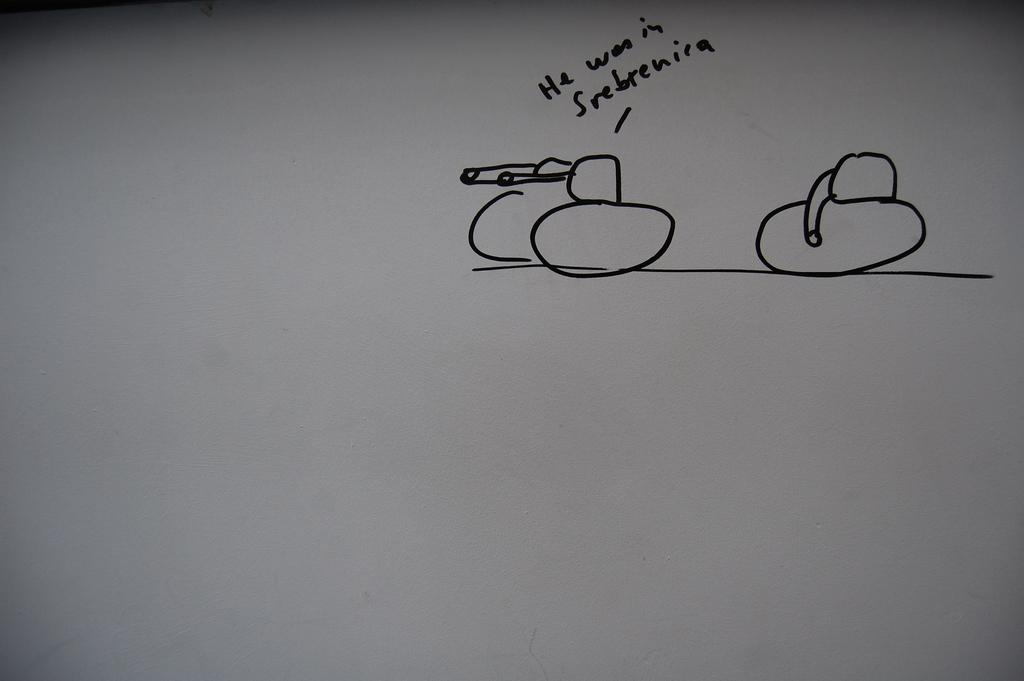<image>
Give a short and clear explanation of the subsequent image. the word he is on the board with other words 